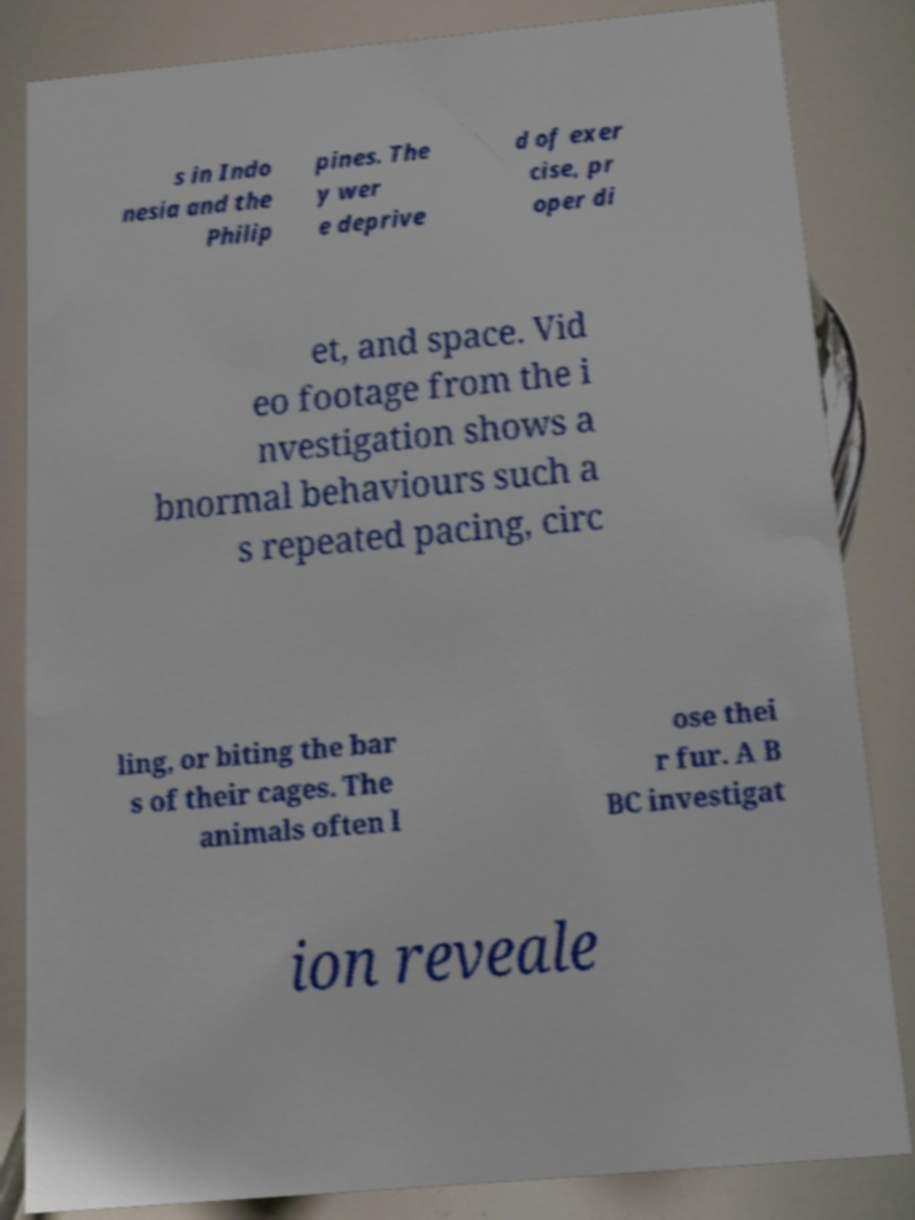Can you accurately transcribe the text from the provided image for me? s in Indo nesia and the Philip pines. The y wer e deprive d of exer cise, pr oper di et, and space. Vid eo footage from the i nvestigation shows a bnormal behaviours such a s repeated pacing, circ ling, or biting the bar s of their cages. The animals often l ose thei r fur. A B BC investigat ion reveale 